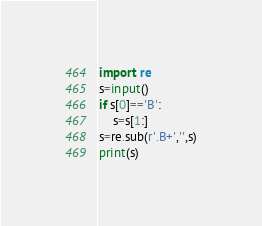Convert code to text. <code><loc_0><loc_0><loc_500><loc_500><_Python_>import re
s=input()
if s[0]=='B':
    s=s[1:]
s=re.sub(r'.B+','',s)
print(s)
</code> 